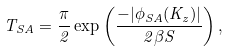<formula> <loc_0><loc_0><loc_500><loc_500>T _ { S A } = \frac { \pi } { 2 } \exp \left ( \frac { - | \phi _ { S A } ( K _ { z } ) | } { 2 \beta S } \right ) ,</formula> 